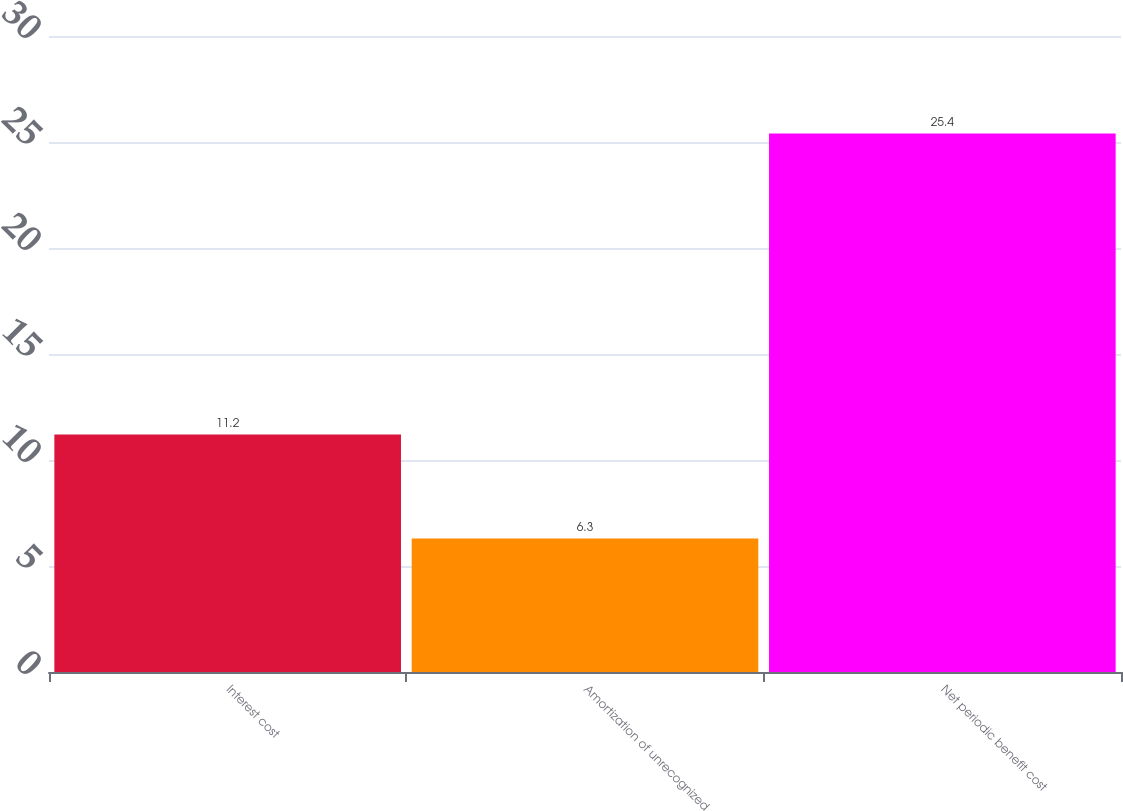<chart> <loc_0><loc_0><loc_500><loc_500><bar_chart><fcel>Interest cost<fcel>Amortization of unrecognized<fcel>Net periodic benefit cost<nl><fcel>11.2<fcel>6.3<fcel>25.4<nl></chart> 